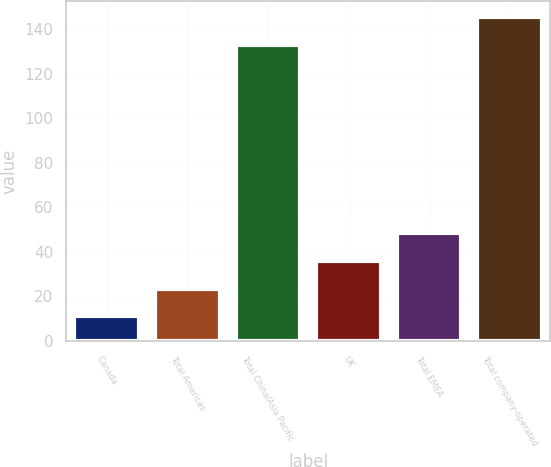Convert chart. <chart><loc_0><loc_0><loc_500><loc_500><bar_chart><fcel>Canada<fcel>Total Americas<fcel>Total China/Asia Pacific<fcel>UK<fcel>Total EMEA<fcel>Total company-operated<nl><fcel>11<fcel>23.5<fcel>133<fcel>36<fcel>48.5<fcel>145.5<nl></chart> 